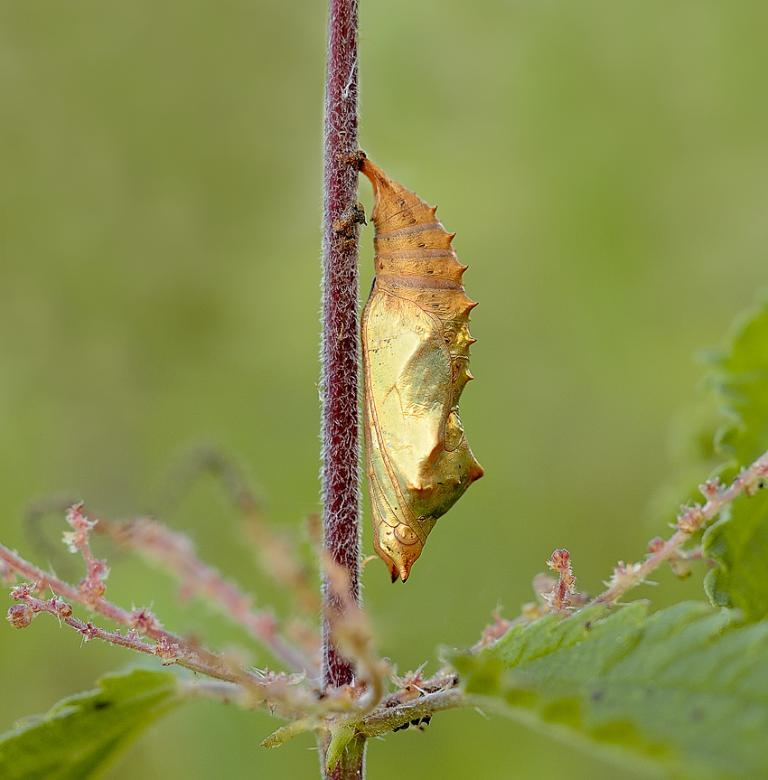What is present on the stem of the plant in the image? There is an insect on the stem of a plant in the image. What else can be seen in the image besides the insect? There are leaves visible in the image. Can you describe the background of the image? The background of the image is blurred. What type of tin can be seen in the image? There is no tin present in the image. Is there a squirrel visible in the image? No, there is no squirrel present in the image. 